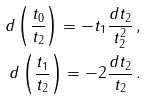Convert formula to latex. <formula><loc_0><loc_0><loc_500><loc_500>d \left ( \frac { t _ { 0 } } { t _ { 2 } } \right ) = - t _ { 1 } \frac { d t _ { 2 } } { t _ { 2 } ^ { 2 } } \, , \\ d \left ( \frac { t _ { 1 } } { t _ { 2 } } \right ) = - 2 \frac { d t _ { 2 } } { t _ { 2 } } \, .</formula> 